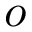Convert formula to latex. <formula><loc_0><loc_0><loc_500><loc_500>o</formula> 